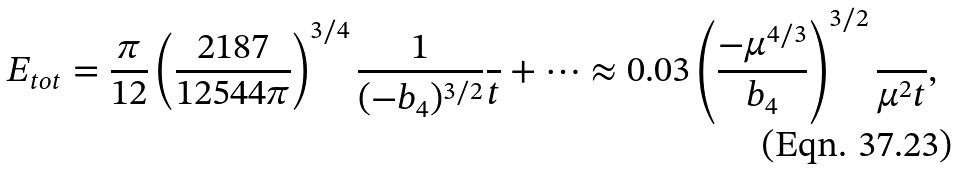Convert formula to latex. <formula><loc_0><loc_0><loc_500><loc_500>E _ { t o t } = \frac { \pi } { 1 2 } \left ( \frac { 2 1 8 7 } { 1 2 5 4 4 \pi } \right ) ^ { 3 / 4 } \frac { 1 } { ( - b _ { 4 } ) ^ { 3 / 2 } } \frac { } { t } + \cdots \approx 0 . 0 3 \left ( \frac { - \mu ^ { 4 / 3 } } { b _ { 4 } } \right ) ^ { 3 / 2 } \frac { } { \mu ^ { 2 } t } ,</formula> 